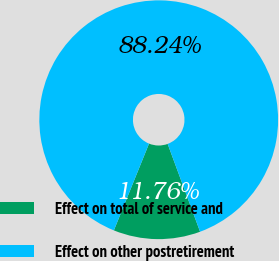Convert chart. <chart><loc_0><loc_0><loc_500><loc_500><pie_chart><fcel>Effect on total of service and<fcel>Effect on other postretirement<nl><fcel>11.76%<fcel>88.24%<nl></chart> 